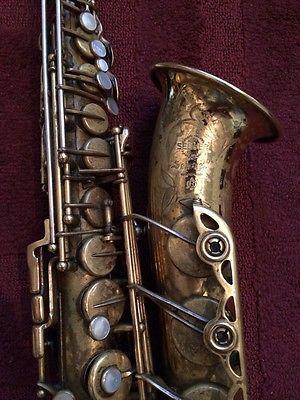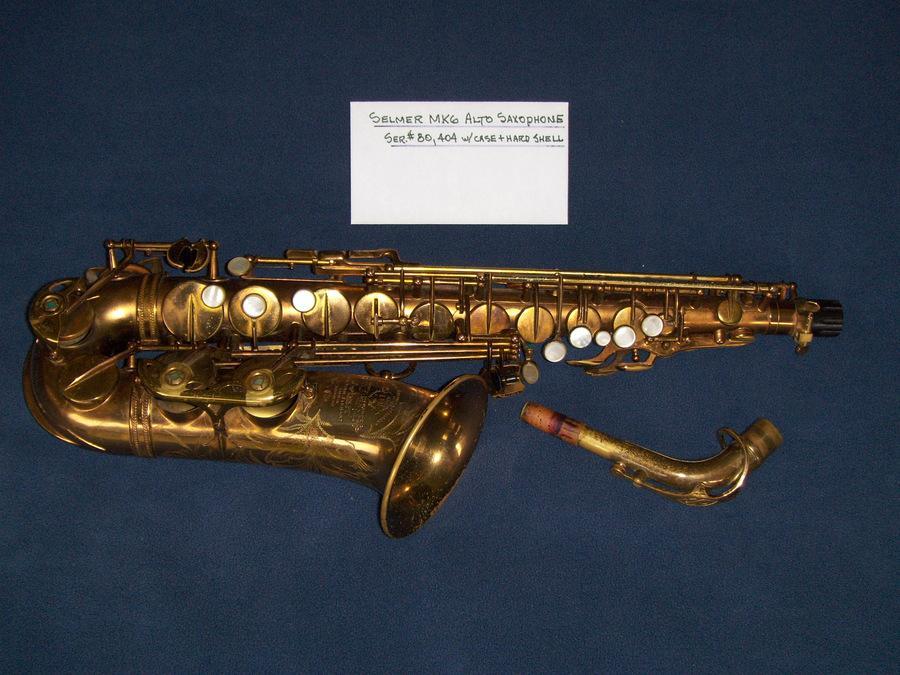The first image is the image on the left, the second image is the image on the right. Analyze the images presented: Is the assertion "One image shows a saxophone with a curved bell end that has its mouthpiece separate and lying near the saxophone's bell." valid? Answer yes or no. Yes. 